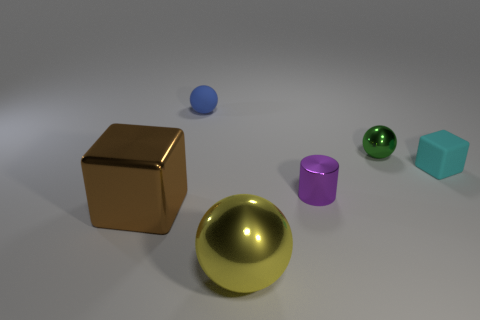Add 2 brown shiny blocks. How many objects exist? 8 Subtract all cubes. How many objects are left? 4 Subtract all yellow shiny balls. Subtract all blue matte objects. How many objects are left? 4 Add 3 small rubber objects. How many small rubber objects are left? 5 Add 6 gray rubber cylinders. How many gray rubber cylinders exist? 6 Subtract 1 blue spheres. How many objects are left? 5 